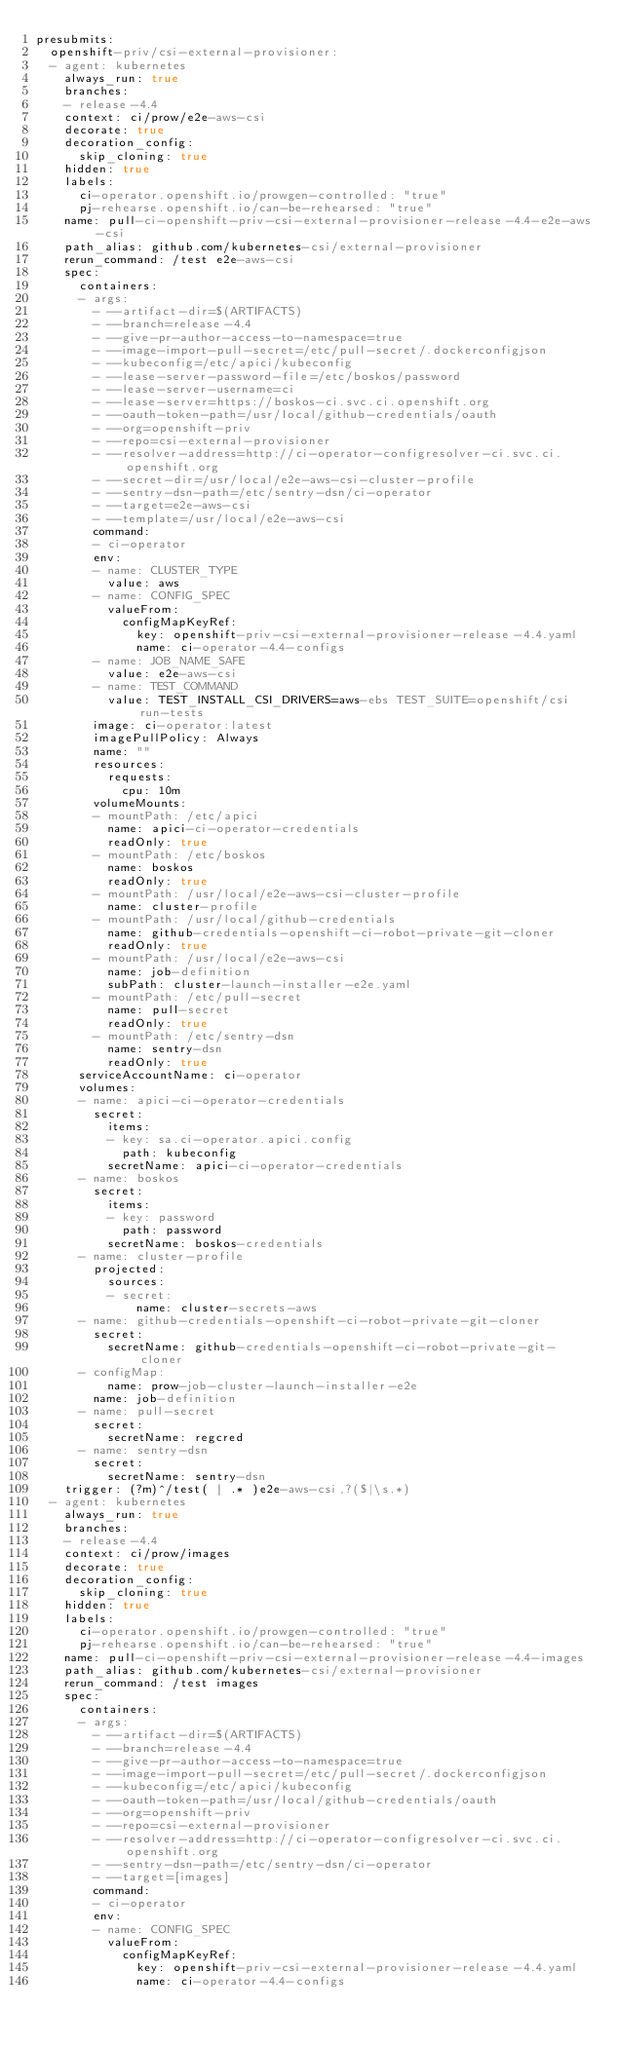Convert code to text. <code><loc_0><loc_0><loc_500><loc_500><_YAML_>presubmits:
  openshift-priv/csi-external-provisioner:
  - agent: kubernetes
    always_run: true
    branches:
    - release-4.4
    context: ci/prow/e2e-aws-csi
    decorate: true
    decoration_config:
      skip_cloning: true
    hidden: true
    labels:
      ci-operator.openshift.io/prowgen-controlled: "true"
      pj-rehearse.openshift.io/can-be-rehearsed: "true"
    name: pull-ci-openshift-priv-csi-external-provisioner-release-4.4-e2e-aws-csi
    path_alias: github.com/kubernetes-csi/external-provisioner
    rerun_command: /test e2e-aws-csi
    spec:
      containers:
      - args:
        - --artifact-dir=$(ARTIFACTS)
        - --branch=release-4.4
        - --give-pr-author-access-to-namespace=true
        - --image-import-pull-secret=/etc/pull-secret/.dockerconfigjson
        - --kubeconfig=/etc/apici/kubeconfig
        - --lease-server-password-file=/etc/boskos/password
        - --lease-server-username=ci
        - --lease-server=https://boskos-ci.svc.ci.openshift.org
        - --oauth-token-path=/usr/local/github-credentials/oauth
        - --org=openshift-priv
        - --repo=csi-external-provisioner
        - --resolver-address=http://ci-operator-configresolver-ci.svc.ci.openshift.org
        - --secret-dir=/usr/local/e2e-aws-csi-cluster-profile
        - --sentry-dsn-path=/etc/sentry-dsn/ci-operator
        - --target=e2e-aws-csi
        - --template=/usr/local/e2e-aws-csi
        command:
        - ci-operator
        env:
        - name: CLUSTER_TYPE
          value: aws
        - name: CONFIG_SPEC
          valueFrom:
            configMapKeyRef:
              key: openshift-priv-csi-external-provisioner-release-4.4.yaml
              name: ci-operator-4.4-configs
        - name: JOB_NAME_SAFE
          value: e2e-aws-csi
        - name: TEST_COMMAND
          value: TEST_INSTALL_CSI_DRIVERS=aws-ebs TEST_SUITE=openshift/csi run-tests
        image: ci-operator:latest
        imagePullPolicy: Always
        name: ""
        resources:
          requests:
            cpu: 10m
        volumeMounts:
        - mountPath: /etc/apici
          name: apici-ci-operator-credentials
          readOnly: true
        - mountPath: /etc/boskos
          name: boskos
          readOnly: true
        - mountPath: /usr/local/e2e-aws-csi-cluster-profile
          name: cluster-profile
        - mountPath: /usr/local/github-credentials
          name: github-credentials-openshift-ci-robot-private-git-cloner
          readOnly: true
        - mountPath: /usr/local/e2e-aws-csi
          name: job-definition
          subPath: cluster-launch-installer-e2e.yaml
        - mountPath: /etc/pull-secret
          name: pull-secret
          readOnly: true
        - mountPath: /etc/sentry-dsn
          name: sentry-dsn
          readOnly: true
      serviceAccountName: ci-operator
      volumes:
      - name: apici-ci-operator-credentials
        secret:
          items:
          - key: sa.ci-operator.apici.config
            path: kubeconfig
          secretName: apici-ci-operator-credentials
      - name: boskos
        secret:
          items:
          - key: password
            path: password
          secretName: boskos-credentials
      - name: cluster-profile
        projected:
          sources:
          - secret:
              name: cluster-secrets-aws
      - name: github-credentials-openshift-ci-robot-private-git-cloner
        secret:
          secretName: github-credentials-openshift-ci-robot-private-git-cloner
      - configMap:
          name: prow-job-cluster-launch-installer-e2e
        name: job-definition
      - name: pull-secret
        secret:
          secretName: regcred
      - name: sentry-dsn
        secret:
          secretName: sentry-dsn
    trigger: (?m)^/test( | .* )e2e-aws-csi,?($|\s.*)
  - agent: kubernetes
    always_run: true
    branches:
    - release-4.4
    context: ci/prow/images
    decorate: true
    decoration_config:
      skip_cloning: true
    hidden: true
    labels:
      ci-operator.openshift.io/prowgen-controlled: "true"
      pj-rehearse.openshift.io/can-be-rehearsed: "true"
    name: pull-ci-openshift-priv-csi-external-provisioner-release-4.4-images
    path_alias: github.com/kubernetes-csi/external-provisioner
    rerun_command: /test images
    spec:
      containers:
      - args:
        - --artifact-dir=$(ARTIFACTS)
        - --branch=release-4.4
        - --give-pr-author-access-to-namespace=true
        - --image-import-pull-secret=/etc/pull-secret/.dockerconfigjson
        - --kubeconfig=/etc/apici/kubeconfig
        - --oauth-token-path=/usr/local/github-credentials/oauth
        - --org=openshift-priv
        - --repo=csi-external-provisioner
        - --resolver-address=http://ci-operator-configresolver-ci.svc.ci.openshift.org
        - --sentry-dsn-path=/etc/sentry-dsn/ci-operator
        - --target=[images]
        command:
        - ci-operator
        env:
        - name: CONFIG_SPEC
          valueFrom:
            configMapKeyRef:
              key: openshift-priv-csi-external-provisioner-release-4.4.yaml
              name: ci-operator-4.4-configs</code> 